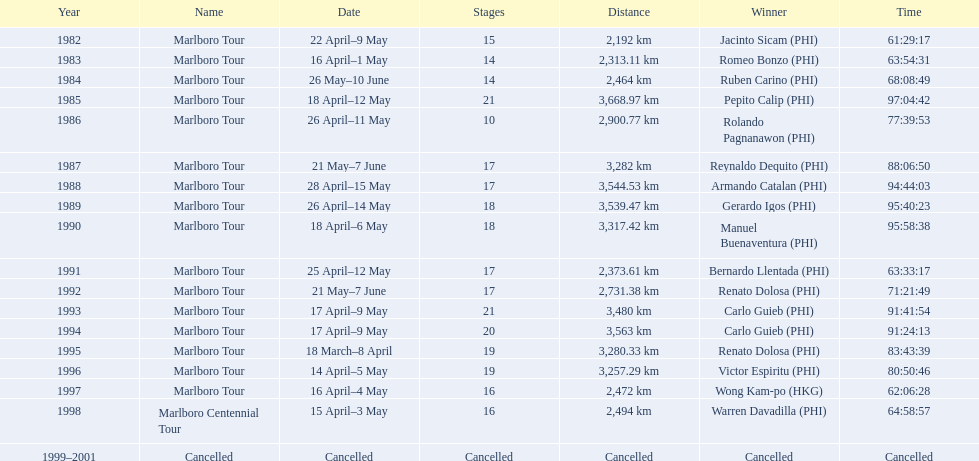What was the competition warren davadilla took part in during 1998? Marlboro Centennial Tour. How much time did davadilla spend to finish the marlboro centennial tour? 64:58:57. 